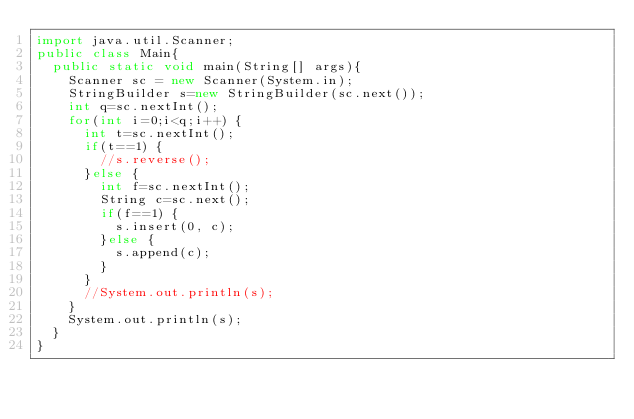Convert code to text. <code><loc_0><loc_0><loc_500><loc_500><_Java_>import java.util.Scanner;
public class Main{
  public static void main(String[] args){
    Scanner sc = new Scanner(System.in);
    StringBuilder s=new StringBuilder(sc.next());
    int q=sc.nextInt();
    for(int i=0;i<q;i++) {
    	int t=sc.nextInt();
    	if(t==1) {
    		//s.reverse();
    	}else {
    		int f=sc.nextInt();
    		String c=sc.next();
    		if(f==1) {
    			s.insert(0, c);
    		}else {
    			s.append(c);
    		}
    	}
    	//System.out.println(s);
    }
    System.out.println(s);
  }
}
</code> 